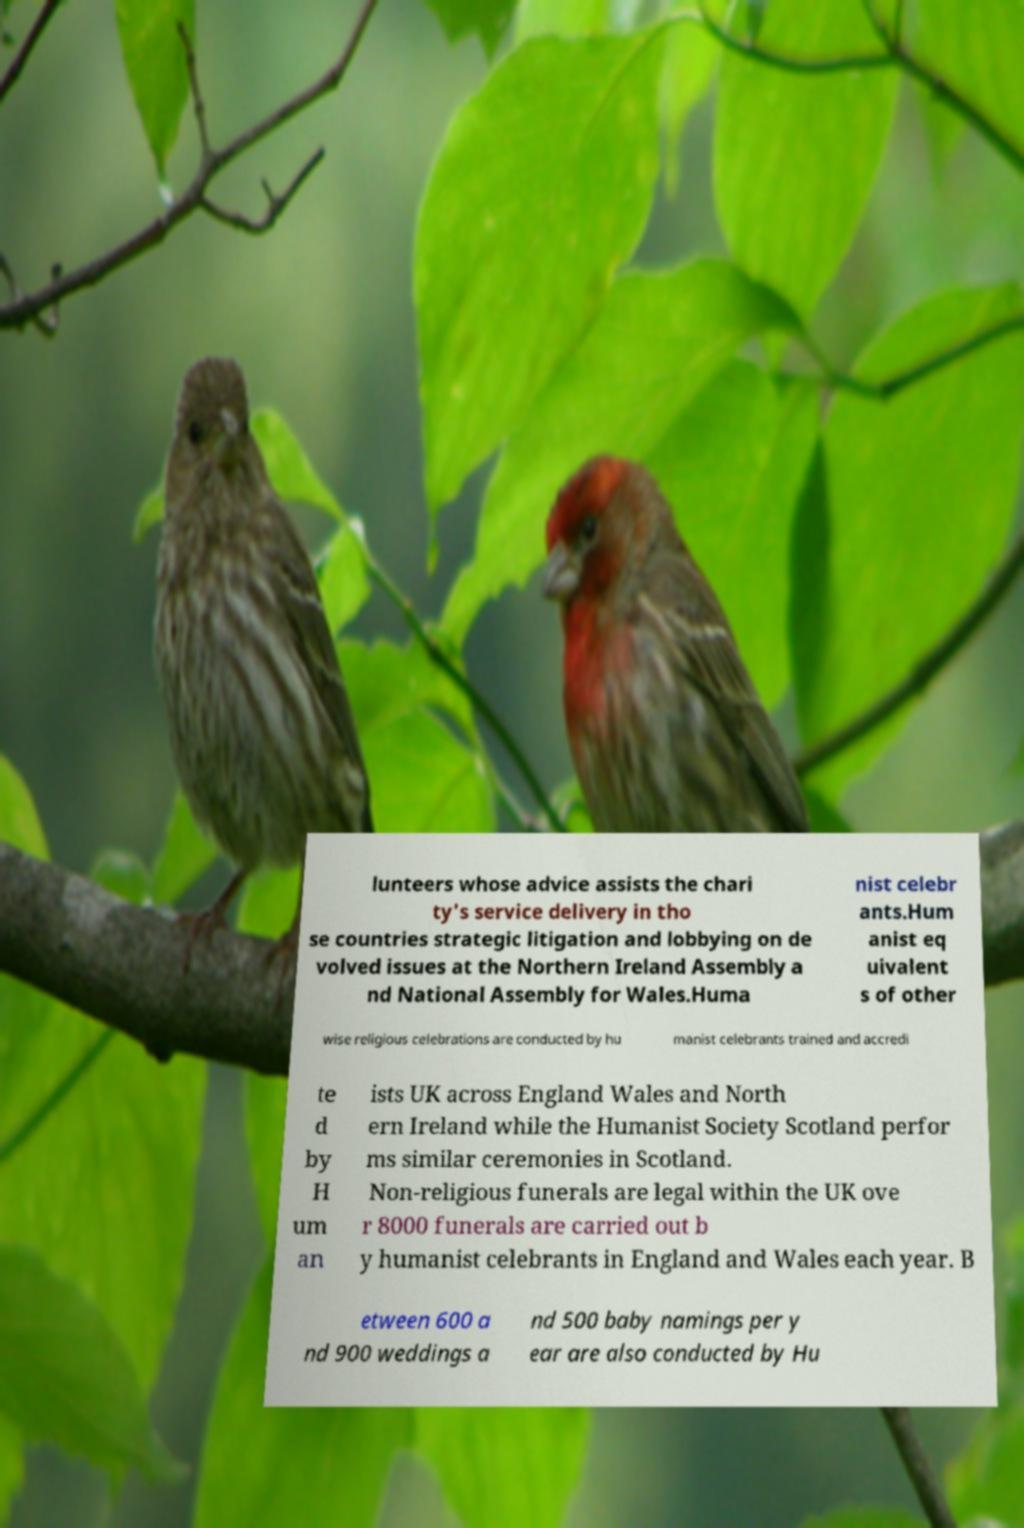Please read and relay the text visible in this image. What does it say? lunteers whose advice assists the chari ty's service delivery in tho se countries strategic litigation and lobbying on de volved issues at the Northern Ireland Assembly a nd National Assembly for Wales.Huma nist celebr ants.Hum anist eq uivalent s of other wise religious celebrations are conducted by hu manist celebrants trained and accredi te d by H um an ists UK across England Wales and North ern Ireland while the Humanist Society Scotland perfor ms similar ceremonies in Scotland. Non-religious funerals are legal within the UK ove r 8000 funerals are carried out b y humanist celebrants in England and Wales each year. B etween 600 a nd 900 weddings a nd 500 baby namings per y ear are also conducted by Hu 